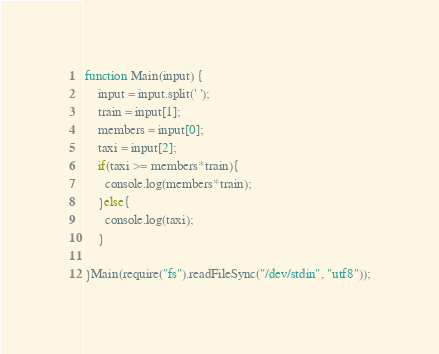Convert code to text. <code><loc_0><loc_0><loc_500><loc_500><_JavaScript_>function Main(input) {
    input = input.split(' ');
  	train = input[1];
  	members = input[0];
	taxi = input[2];
	if(taxi >= members*train){
      console.log(members*train);
    }else{
      console.log(taxi);
    }
  
}Main(require("fs").readFileSync("/dev/stdin", "utf8"));</code> 